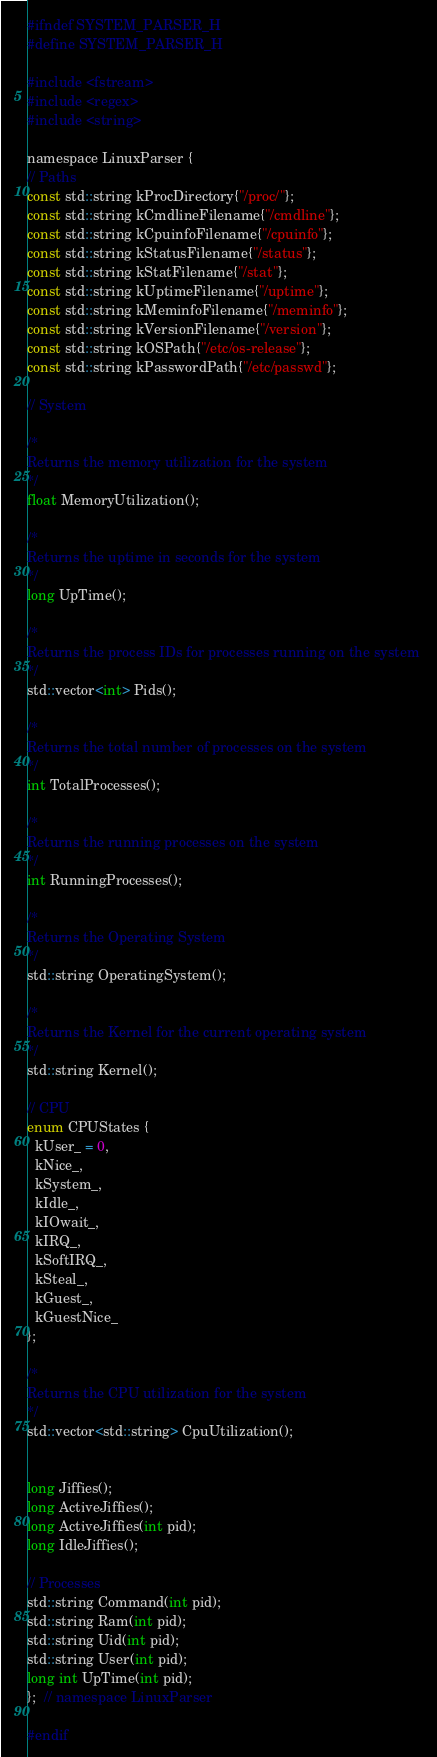Convert code to text. <code><loc_0><loc_0><loc_500><loc_500><_C_>#ifndef SYSTEM_PARSER_H
#define SYSTEM_PARSER_H

#include <fstream>
#include <regex>
#include <string>

namespace LinuxParser {
// Paths
const std::string kProcDirectory{"/proc/"};
const std::string kCmdlineFilename{"/cmdline"};
const std::string kCpuinfoFilename{"/cpuinfo"};
const std::string kStatusFilename{"/status"};
const std::string kStatFilename{"/stat"};
const std::string kUptimeFilename{"/uptime"};
const std::string kMeminfoFilename{"/meminfo"};
const std::string kVersionFilename{"/version"};
const std::string kOSPath{"/etc/os-release"};
const std::string kPasswordPath{"/etc/passwd"};

// System

/*
Returns the memory utilization for the system
*/
float MemoryUtilization();

/*
Returns the uptime in seconds for the system 
*/
long UpTime();

/*
Returns the process IDs for processes running on the system 
*/
std::vector<int> Pids();

/*
Returns the total number of processes on the system
*/
int TotalProcesses();

/*
Returns the running processes on the system
*/
int RunningProcesses();

/*
Returns the Operating System 
*/
std::string OperatingSystem();

/*
Returns the Kernel for the current operating system
*/
std::string Kernel();

// CPU
enum CPUStates {
  kUser_ = 0,
  kNice_,
  kSystem_,
  kIdle_,
  kIOwait_,
  kIRQ_,
  kSoftIRQ_,
  kSteal_,
  kGuest_,
  kGuestNice_
};

/*
Returns the CPU utilization for the system
*/
std::vector<std::string> CpuUtilization();


long Jiffies();
long ActiveJiffies();
long ActiveJiffies(int pid);
long IdleJiffies();

// Processes
std::string Command(int pid);
std::string Ram(int pid);
std::string Uid(int pid);
std::string User(int pid);
long int UpTime(int pid);
};  // namespace LinuxParser

#endif</code> 